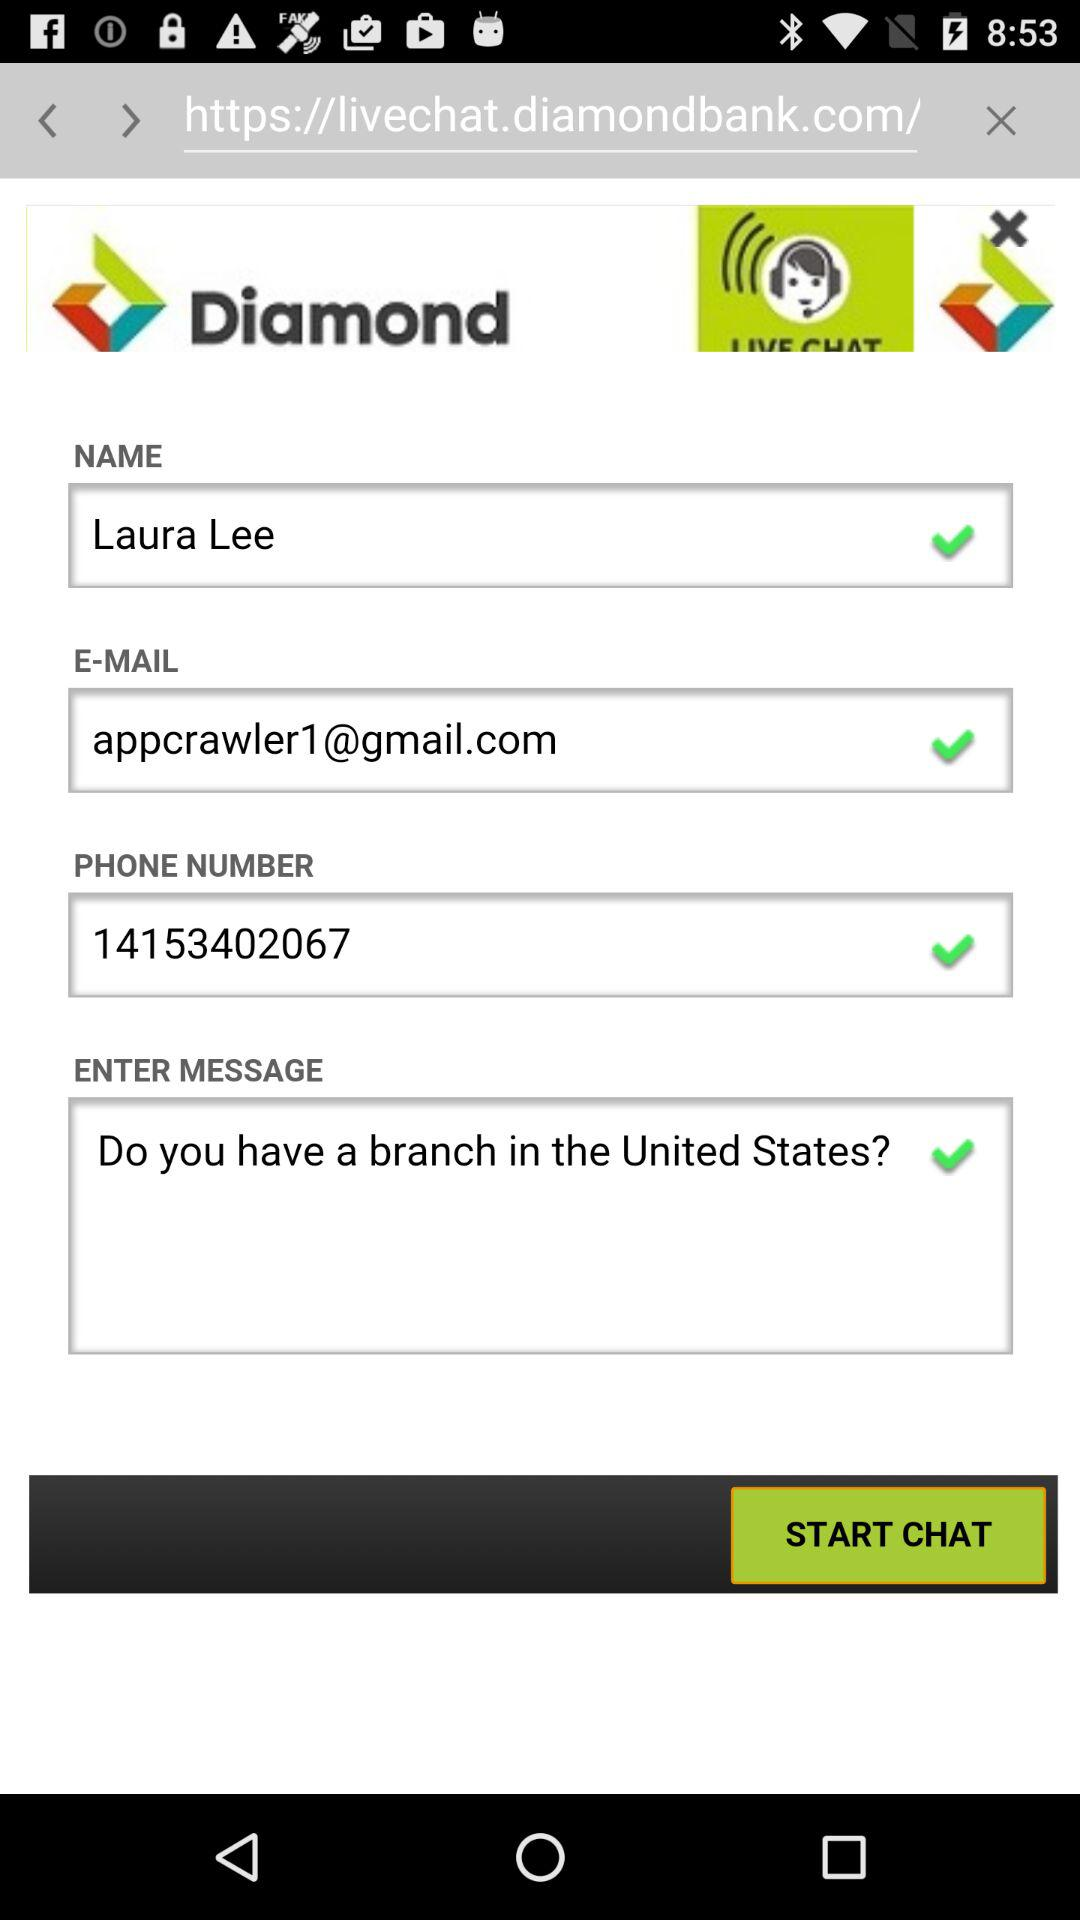What is the phone number? The phone number is 14153402067. 